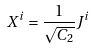<formula> <loc_0><loc_0><loc_500><loc_500>X ^ { i } = \frac { 1 } { \sqrt { C _ { 2 } } } J ^ { i }</formula> 